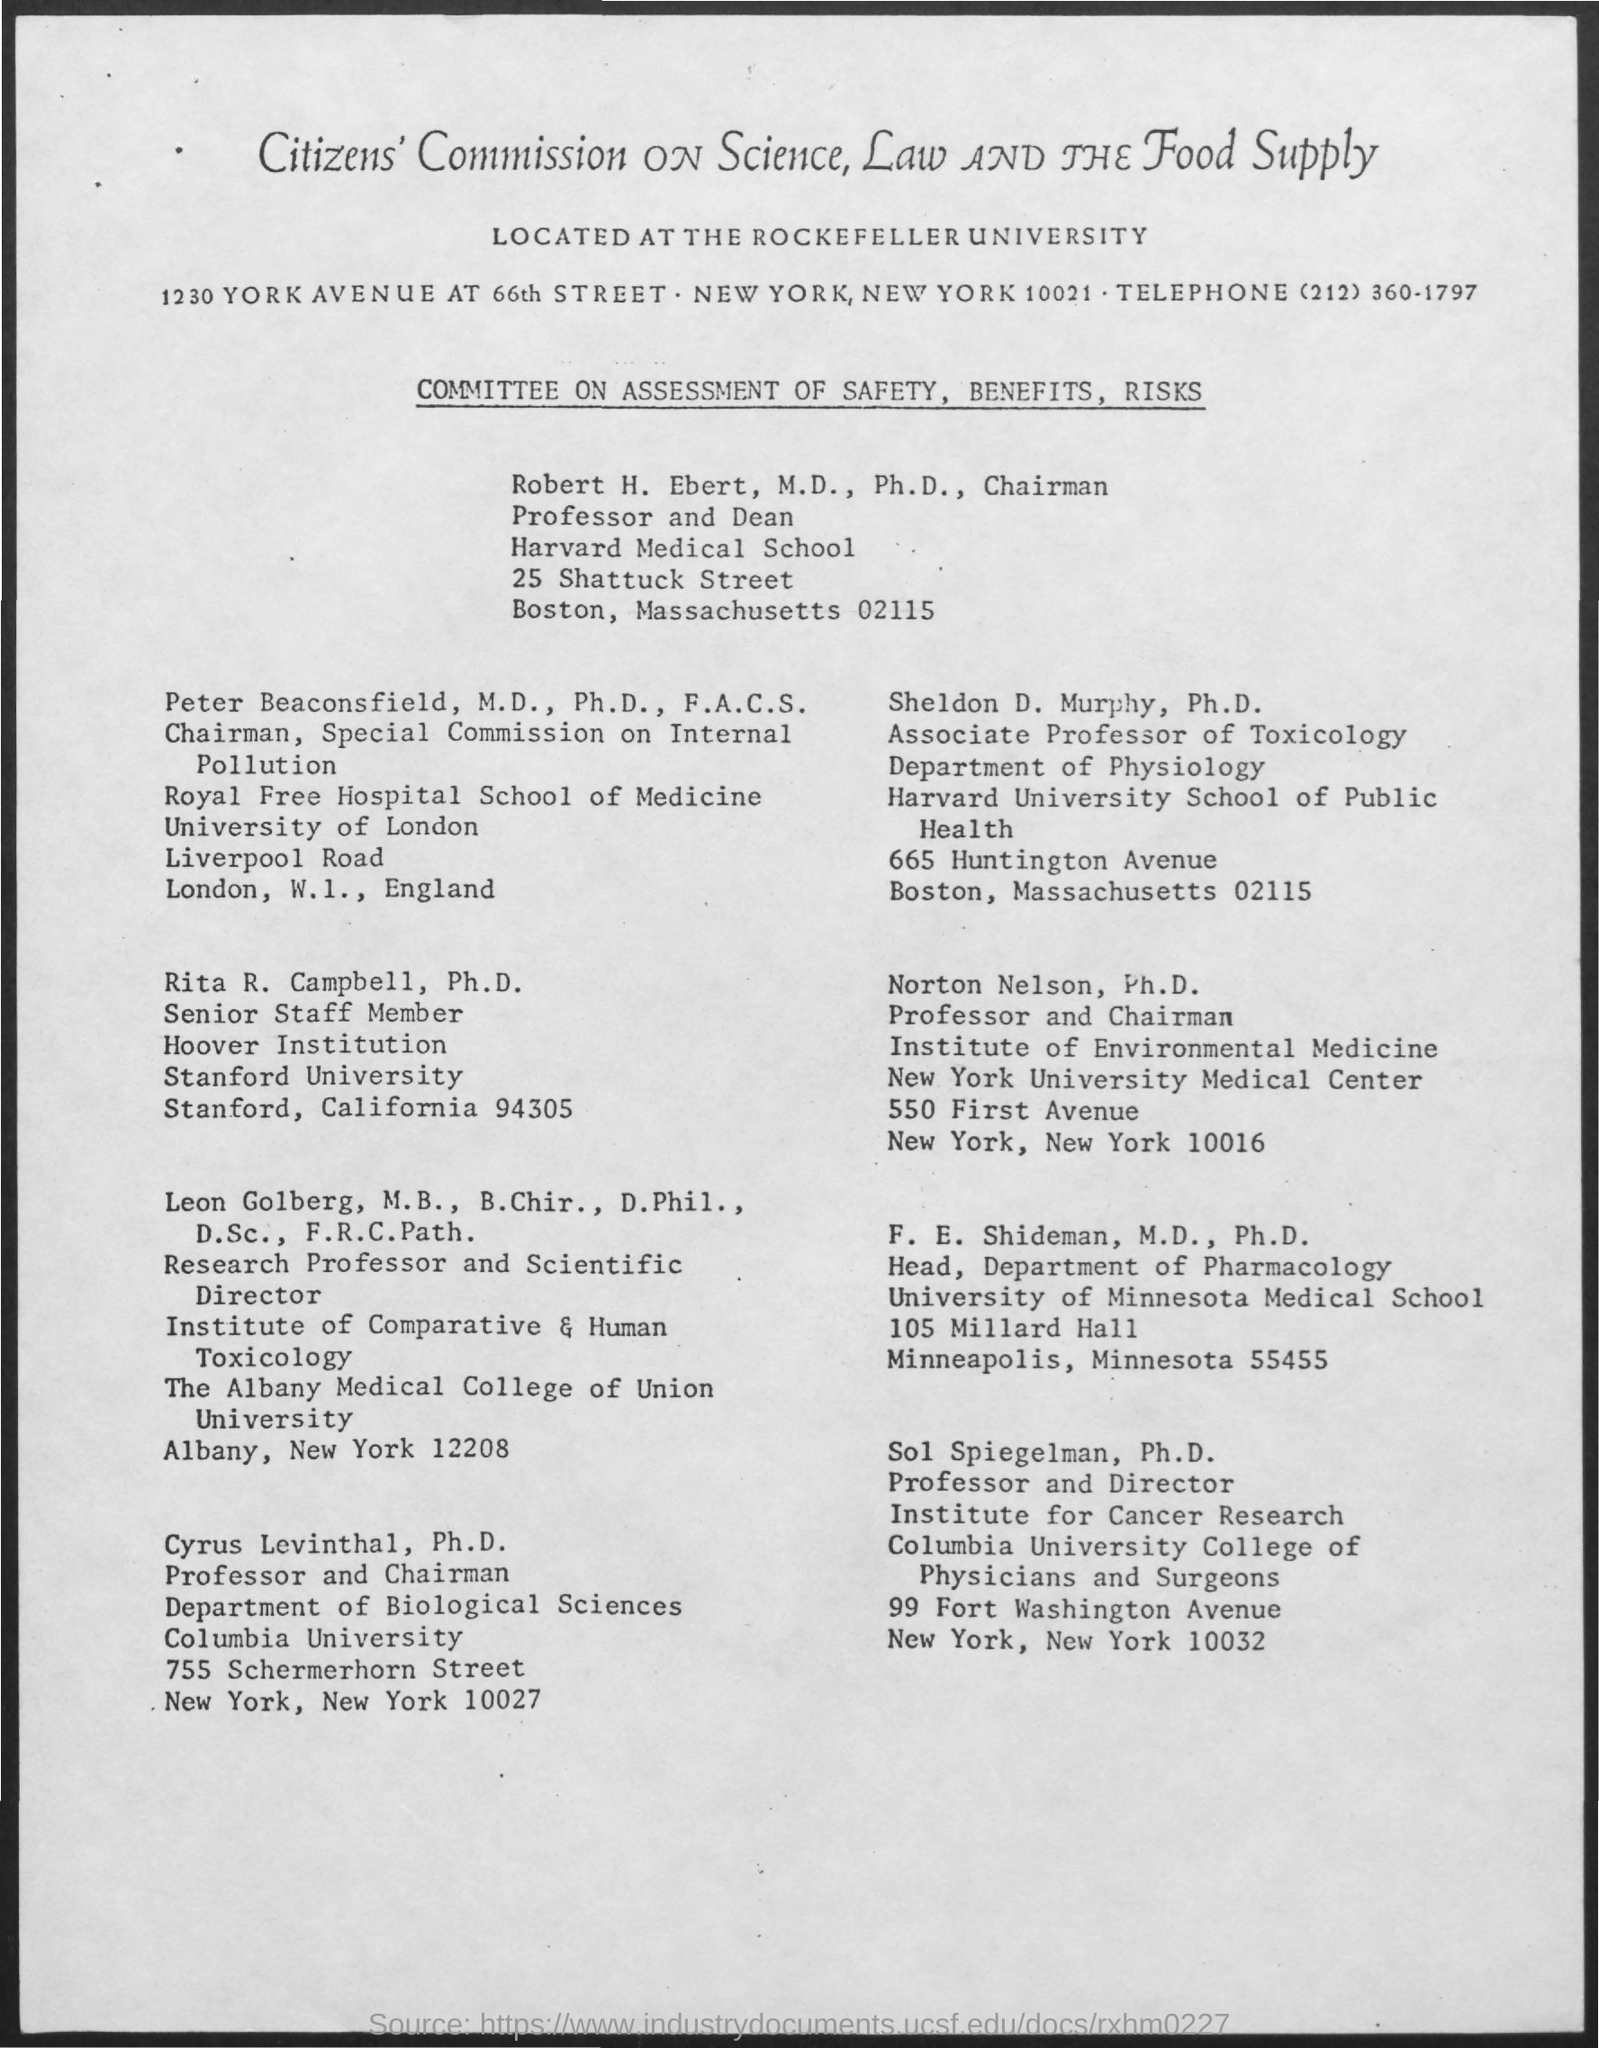List a handful of essential elements in this visual. F. E. Shideman is the head of the Department of Pharmacology. The telephone number is (212) 360-1797. Sheldon D. Murphy is an Associate Professor of Toxicology. The Professor and Chairman of the Department of Biological Sciences is Cyrus Levinthal. The title of the commission is the "Citizens' Commission on Science, Law, and the Food Supply. 